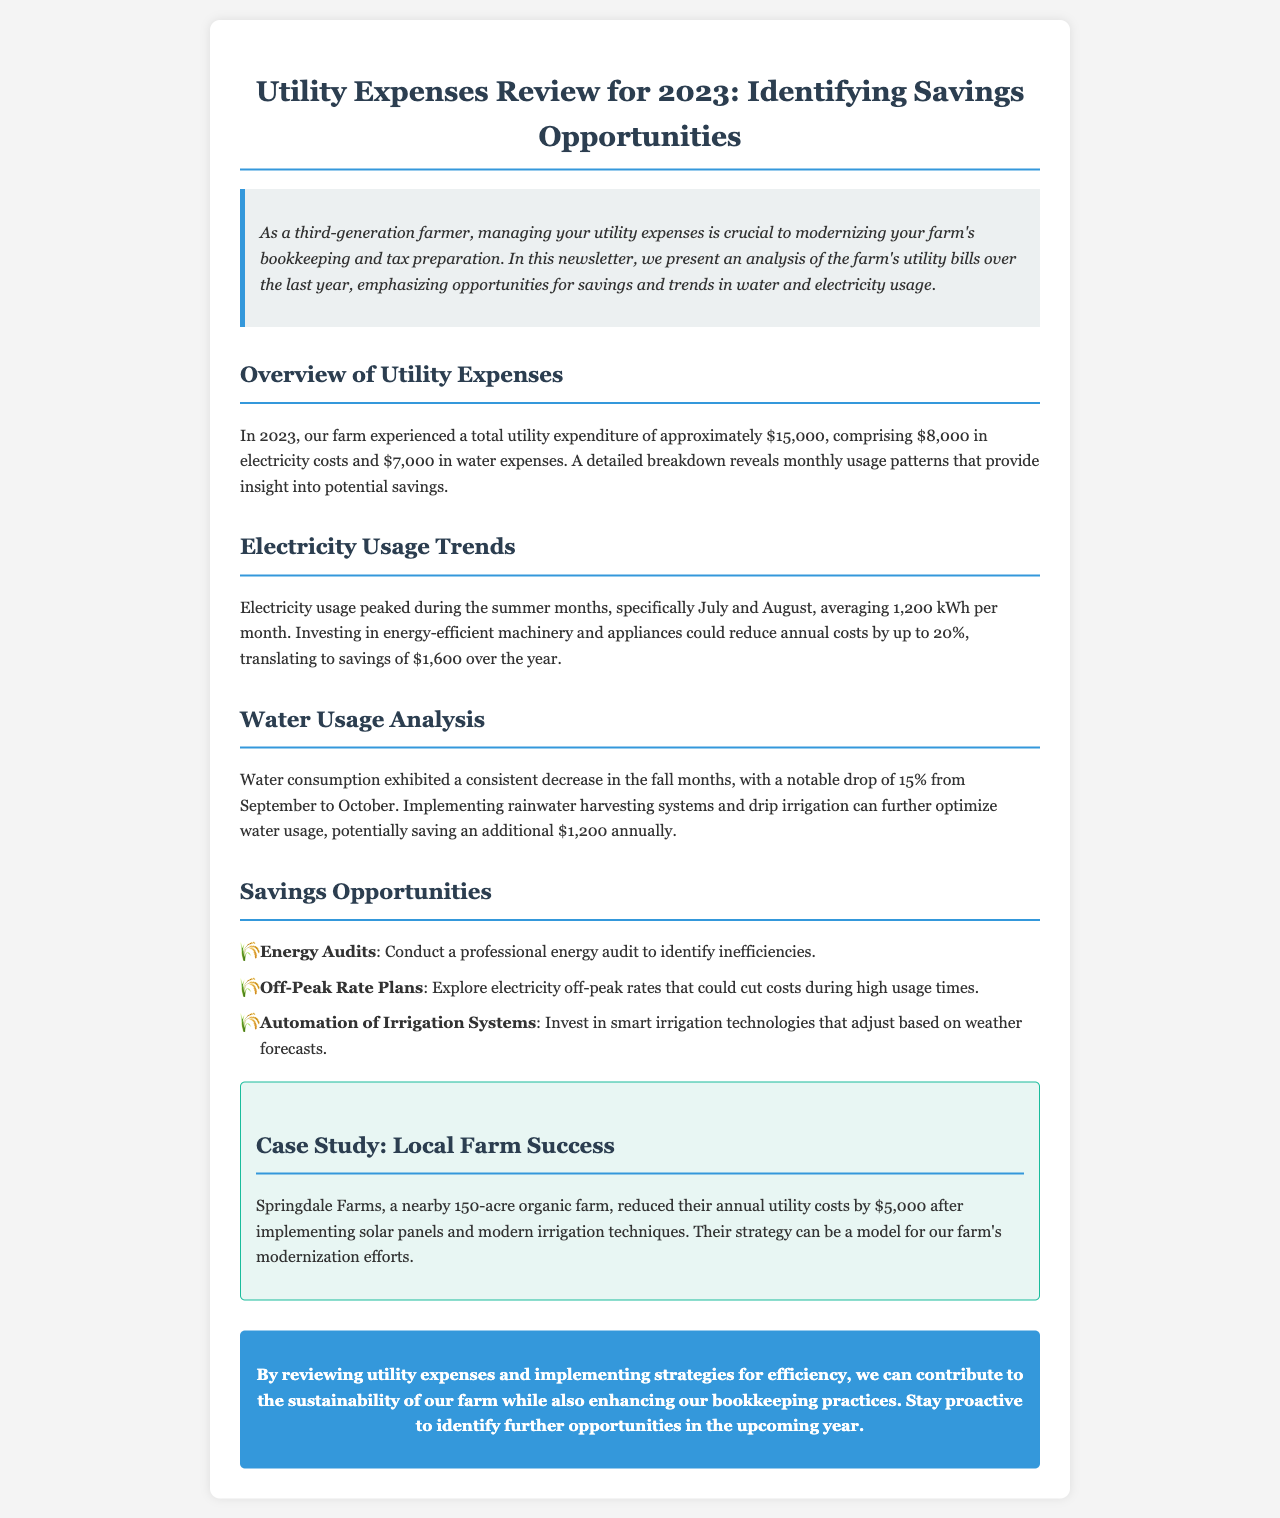what is the total utility expenditure for 2023? The total utility expenditure is the sum of electricity costs and water expenses, which amounts to $8,000 + $7,000 = $15,000.
Answer: $15,000 how much did the farm spend on electricity? The document states that the farm spent $8,000 on electricity.
Answer: $8,000 what percentage reduction in annual costs can investing in energy-efficient machinery lead to? The document indicates that investing in energy-efficient machinery could reduce annual costs by up to 20%.
Answer: 20% which month showed a peak in electricity usage? The peak electricity usage occurred in July and August.
Answer: July and August what is a key strategy for optimizing water usage mentioned in the newsletter? The newsletter suggests implementing rainwater harvesting systems as a key strategy.
Answer: rainwater harvesting systems how much did Springdale Farms save after implementing solar panels? The case study mentions that Springdale Farms reduced their annual utility costs by $5,000 after implementing solar panels.
Answer: $5,000 what type of audit is recommended to identify inefficiencies? The document recommends conducting a professional energy audit.
Answer: professional energy audit how much additional savings can rainwater harvesting potentially provide annually? The newsletter states that rainwater harvesting can potentially save an additional $1,200 annually.
Answer: $1,200 what irrigation technology investment is suggested in the newsletter? The newsletter suggests investing in smart irrigation technologies.
Answer: smart irrigation technologies 